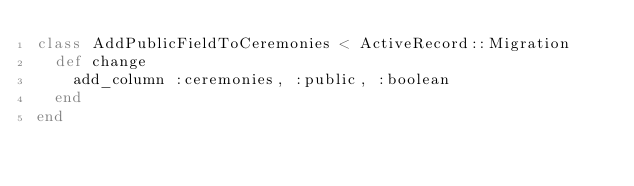<code> <loc_0><loc_0><loc_500><loc_500><_Ruby_>class AddPublicFieldToCeremonies < ActiveRecord::Migration
  def change
    add_column :ceremonies, :public, :boolean
  end
end
</code> 